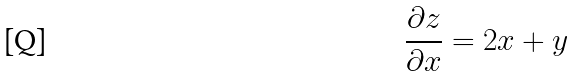Convert formula to latex. <formula><loc_0><loc_0><loc_500><loc_500>\frac { \partial z } { \partial x } = 2 x + y</formula> 